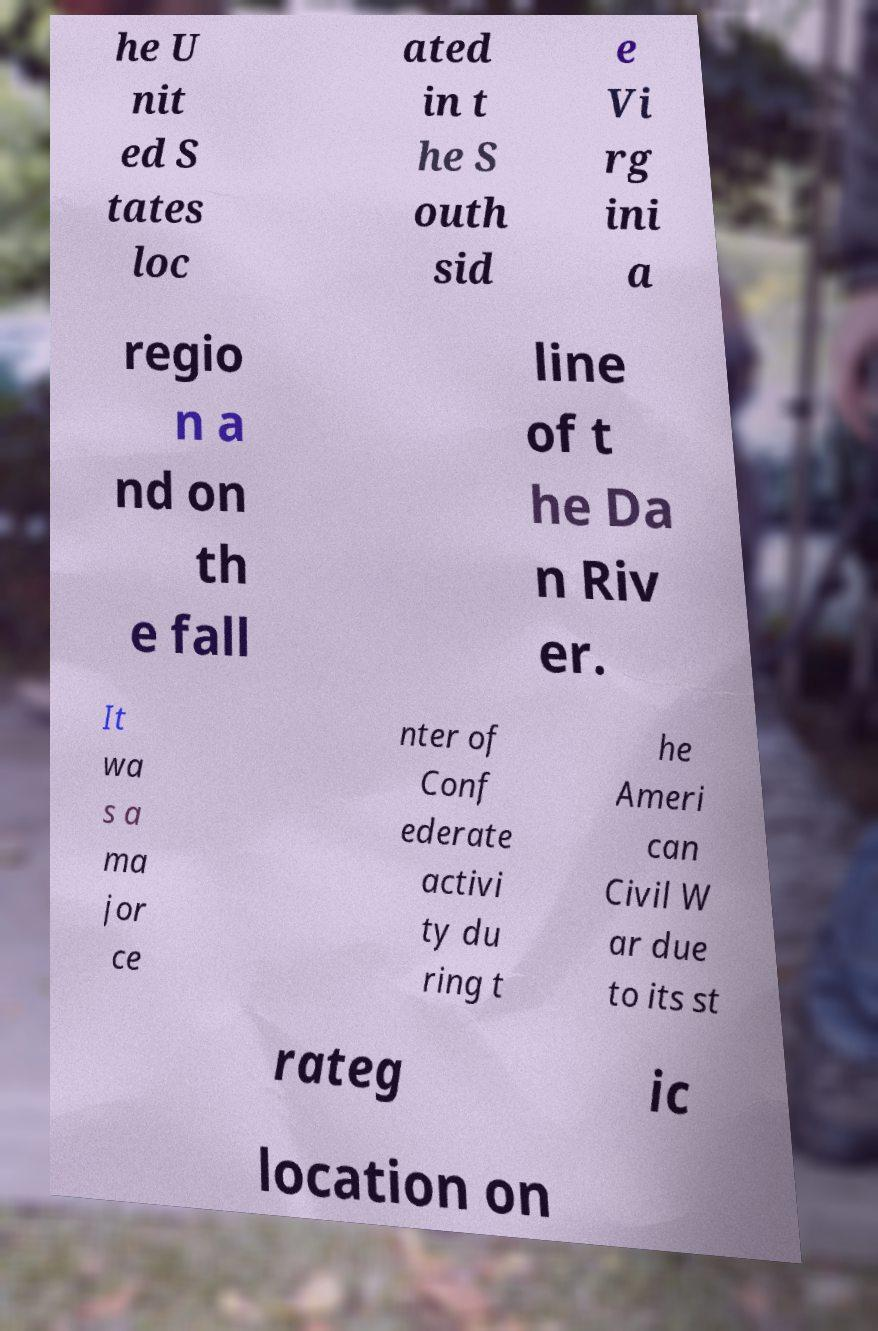There's text embedded in this image that I need extracted. Can you transcribe it verbatim? he U nit ed S tates loc ated in t he S outh sid e Vi rg ini a regio n a nd on th e fall line of t he Da n Riv er. It wa s a ma jor ce nter of Conf ederate activi ty du ring t he Ameri can Civil W ar due to its st rateg ic location on 